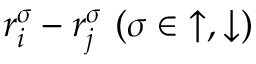Convert formula to latex. <formula><loc_0><loc_0><loc_500><loc_500>r _ { i } ^ { \sigma } - r _ { j } ^ { \sigma } ( \sigma \in { \uparrow , \downarrow } )</formula> 